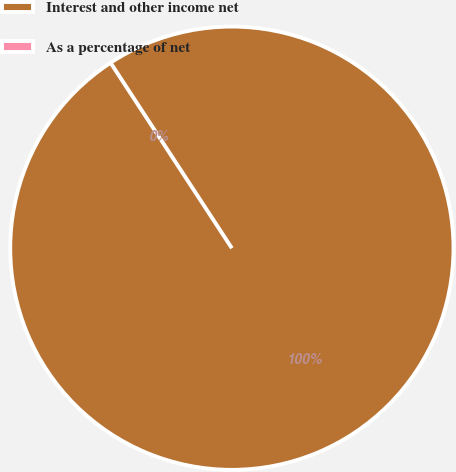Convert chart to OTSL. <chart><loc_0><loc_0><loc_500><loc_500><pie_chart><fcel>Interest and other income net<fcel>As a percentage of net<nl><fcel>100.0%<fcel>0.0%<nl></chart> 